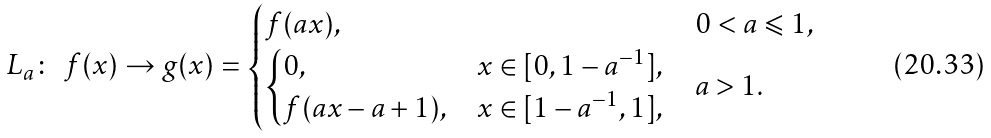Convert formula to latex. <formula><loc_0><loc_0><loc_500><loc_500>L _ { a } \colon \ f ( x ) \to g ( x ) = \begin{cases} f ( a x ) , & 0 < a \leqslant 1 , \\ \begin{cases} 0 , & x \in [ 0 , 1 - a ^ { - 1 } ] , \\ f ( a x - a + 1 ) , & x \in [ 1 - a ^ { - 1 } , 1 ] , \end{cases} & a > 1 . \end{cases}</formula> 